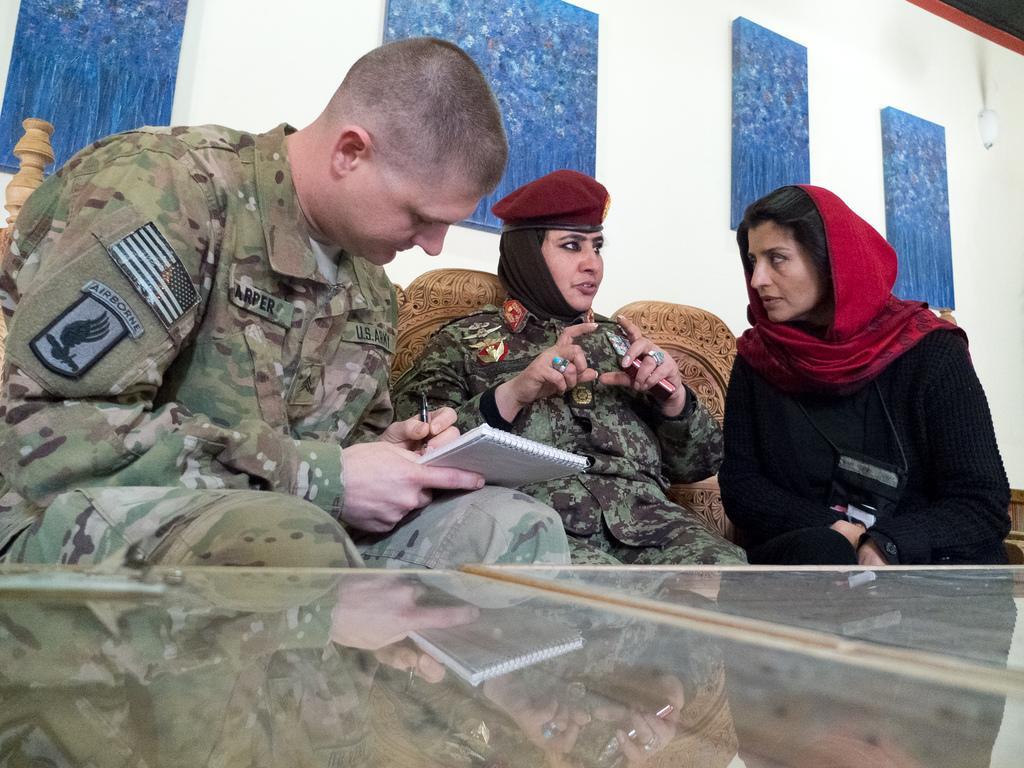Describe this image in one or two sentences. In this image we can see two women sitting. We can also see a man sitting and holding the pen and also the book. Image also consists of the glass table. In the background we can see some blue color boards attached to the wall. We can also see the light. 